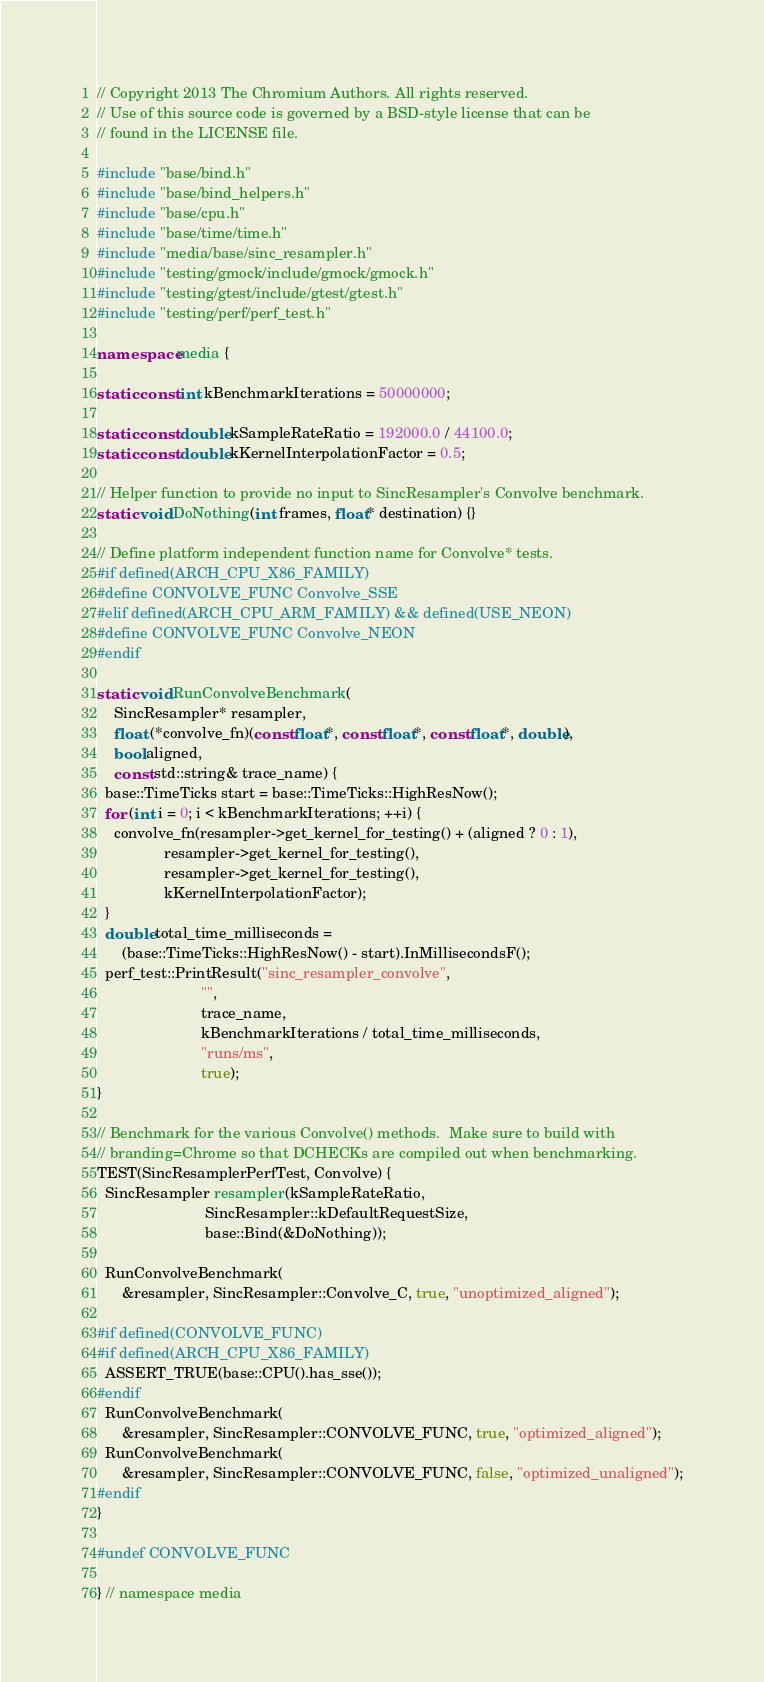<code> <loc_0><loc_0><loc_500><loc_500><_C++_>// Copyright 2013 The Chromium Authors. All rights reserved.
// Use of this source code is governed by a BSD-style license that can be
// found in the LICENSE file.

#include "base/bind.h"
#include "base/bind_helpers.h"
#include "base/cpu.h"
#include "base/time/time.h"
#include "media/base/sinc_resampler.h"
#include "testing/gmock/include/gmock/gmock.h"
#include "testing/gtest/include/gtest/gtest.h"
#include "testing/perf/perf_test.h"

namespace media {

static const int kBenchmarkIterations = 50000000;

static const double kSampleRateRatio = 192000.0 / 44100.0;
static const double kKernelInterpolationFactor = 0.5;

// Helper function to provide no input to SincResampler's Convolve benchmark.
static void DoNothing(int frames, float* destination) {}

// Define platform independent function name for Convolve* tests.
#if defined(ARCH_CPU_X86_FAMILY)
#define CONVOLVE_FUNC Convolve_SSE
#elif defined(ARCH_CPU_ARM_FAMILY) && defined(USE_NEON)
#define CONVOLVE_FUNC Convolve_NEON
#endif

static void RunConvolveBenchmark(
    SincResampler* resampler,
    float (*convolve_fn)(const float*, const float*, const float*, double),
    bool aligned,
    const std::string& trace_name) {
  base::TimeTicks start = base::TimeTicks::HighResNow();
  for (int i = 0; i < kBenchmarkIterations; ++i) {
    convolve_fn(resampler->get_kernel_for_testing() + (aligned ? 0 : 1),
                resampler->get_kernel_for_testing(),
                resampler->get_kernel_for_testing(),
                kKernelInterpolationFactor);
  }
  double total_time_milliseconds =
      (base::TimeTicks::HighResNow() - start).InMillisecondsF();
  perf_test::PrintResult("sinc_resampler_convolve",
                         "",
                         trace_name,
                         kBenchmarkIterations / total_time_milliseconds,
                         "runs/ms",
                         true);
}

// Benchmark for the various Convolve() methods.  Make sure to build with
// branding=Chrome so that DCHECKs are compiled out when benchmarking.
TEST(SincResamplerPerfTest, Convolve) {
  SincResampler resampler(kSampleRateRatio,
                          SincResampler::kDefaultRequestSize,
                          base::Bind(&DoNothing));

  RunConvolveBenchmark(
      &resampler, SincResampler::Convolve_C, true, "unoptimized_aligned");

#if defined(CONVOLVE_FUNC)
#if defined(ARCH_CPU_X86_FAMILY)
  ASSERT_TRUE(base::CPU().has_sse());
#endif
  RunConvolveBenchmark(
      &resampler, SincResampler::CONVOLVE_FUNC, true, "optimized_aligned");
  RunConvolveBenchmark(
      &resampler, SincResampler::CONVOLVE_FUNC, false, "optimized_unaligned");
#endif
}

#undef CONVOLVE_FUNC

} // namespace media
</code> 